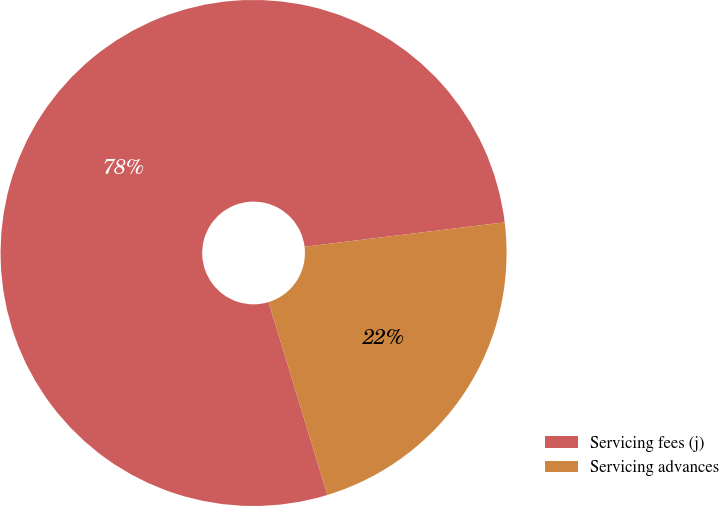<chart> <loc_0><loc_0><loc_500><loc_500><pie_chart><fcel>Servicing fees (j)<fcel>Servicing advances<nl><fcel>77.78%<fcel>22.22%<nl></chart> 